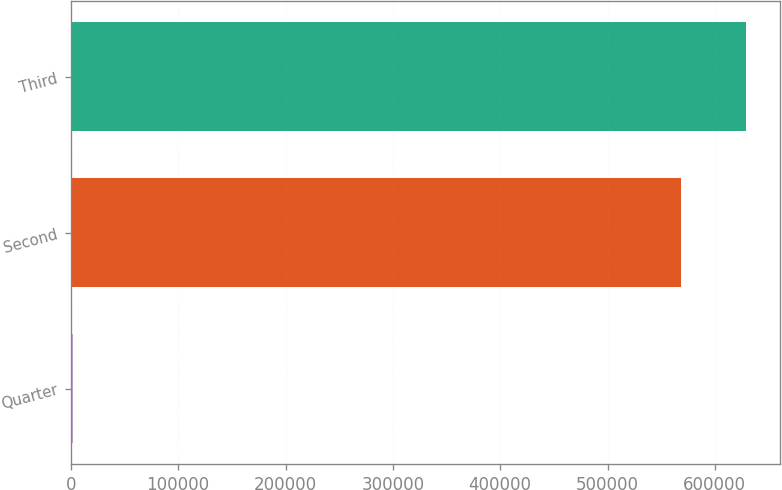<chart> <loc_0><loc_0><loc_500><loc_500><bar_chart><fcel>Quarter<fcel>Second<fcel>Third<nl><fcel>2009<fcel>568261<fcel>629324<nl></chart> 